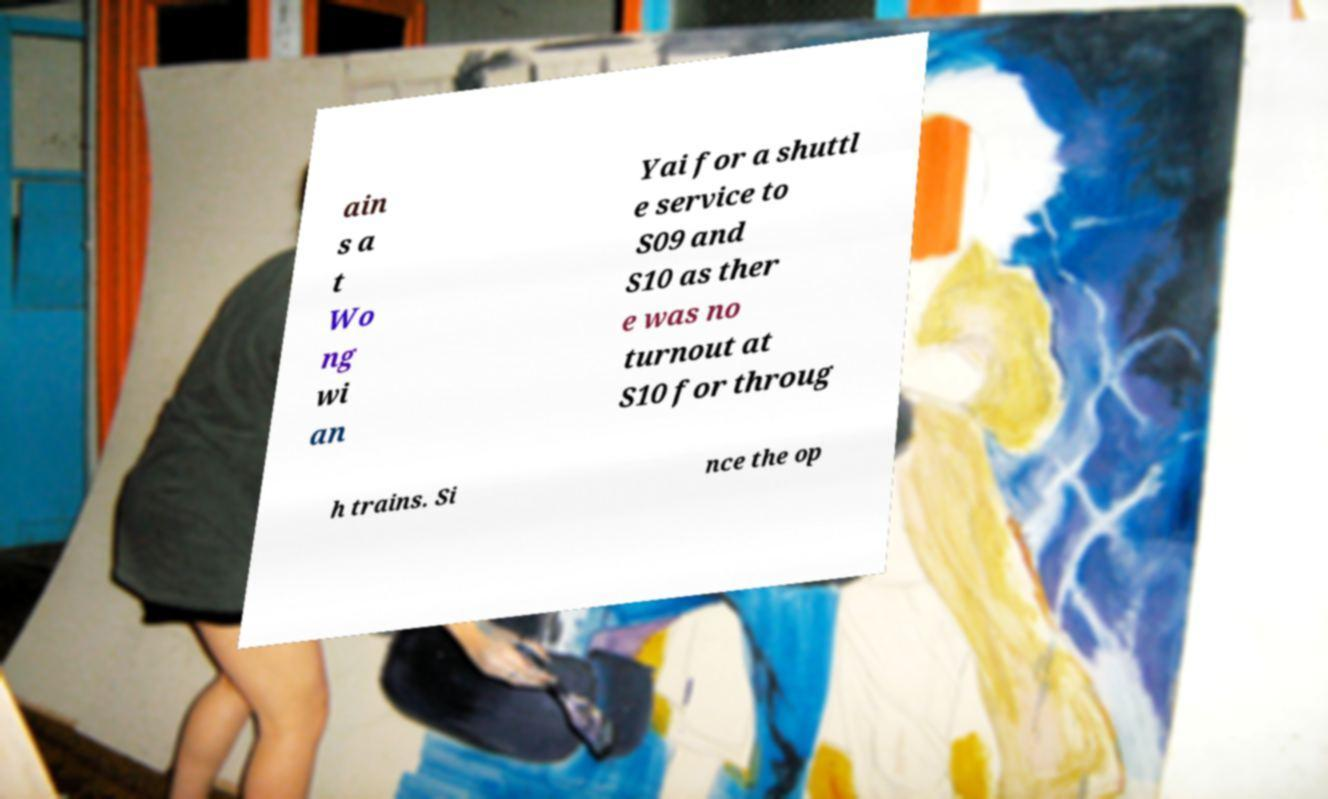What messages or text are displayed in this image? I need them in a readable, typed format. ain s a t Wo ng wi an Yai for a shuttl e service to S09 and S10 as ther e was no turnout at S10 for throug h trains. Si nce the op 